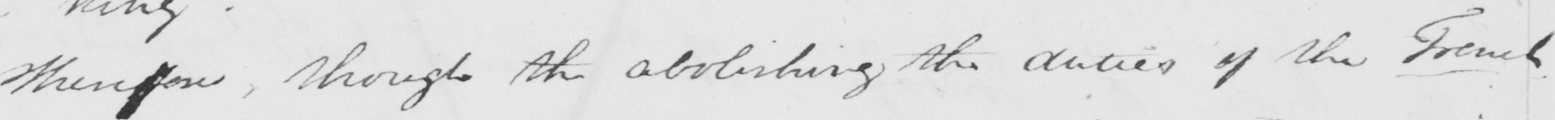What does this handwritten line say? Therefore , though the abolishing the duties of the French 